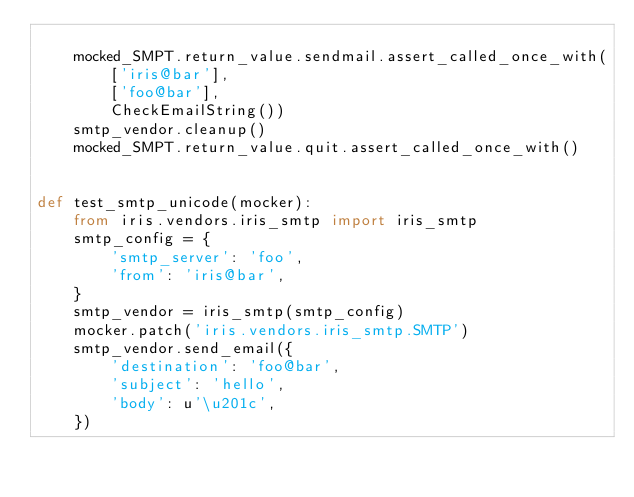<code> <loc_0><loc_0><loc_500><loc_500><_Python_>
    mocked_SMPT.return_value.sendmail.assert_called_once_with(
        ['iris@bar'],
        ['foo@bar'],
        CheckEmailString())
    smtp_vendor.cleanup()
    mocked_SMPT.return_value.quit.assert_called_once_with()


def test_smtp_unicode(mocker):
    from iris.vendors.iris_smtp import iris_smtp
    smtp_config = {
        'smtp_server': 'foo',
        'from': 'iris@bar',
    }
    smtp_vendor = iris_smtp(smtp_config)
    mocker.patch('iris.vendors.iris_smtp.SMTP')
    smtp_vendor.send_email({
        'destination': 'foo@bar',
        'subject': 'hello',
        'body': u'\u201c',
    })
</code> 